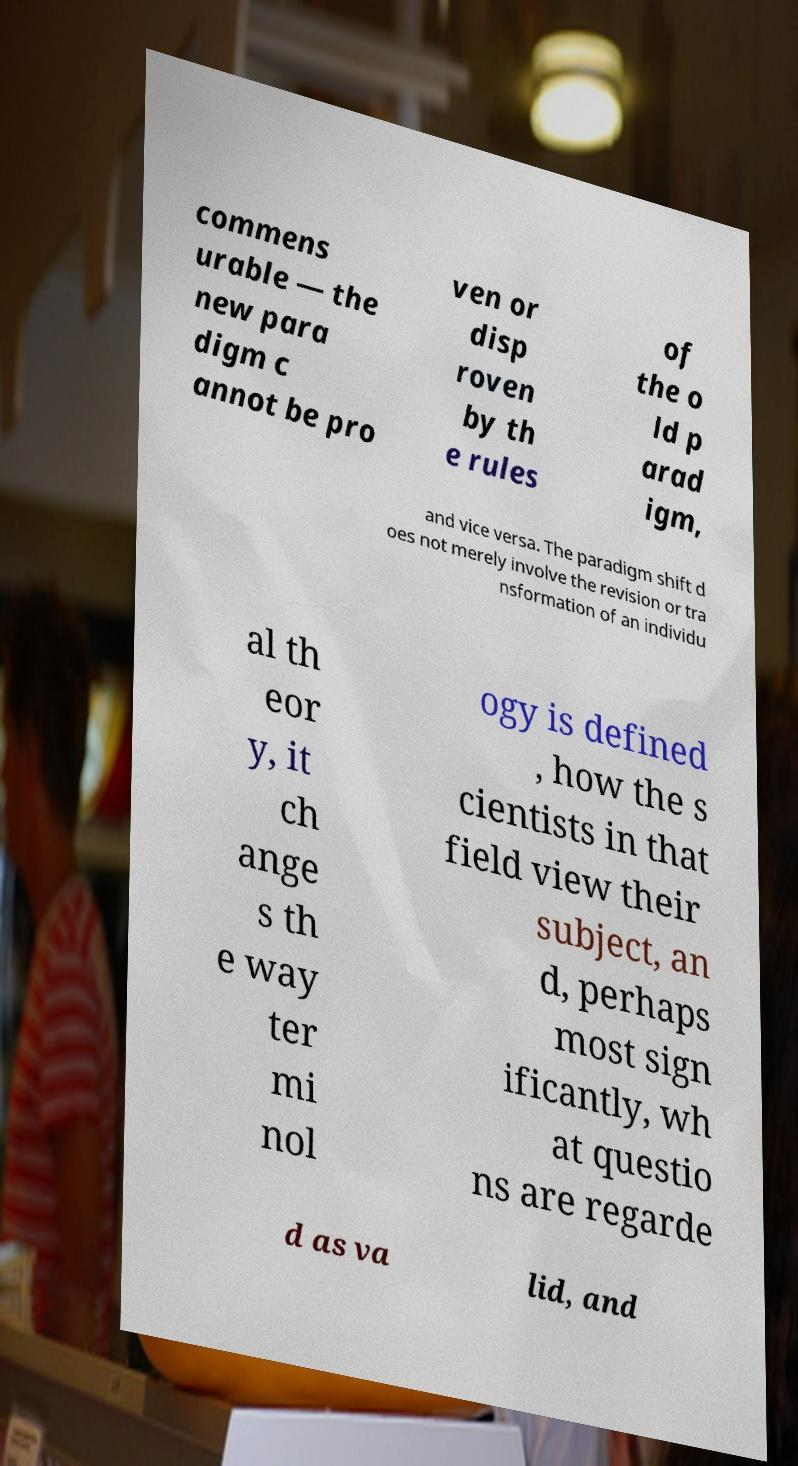What messages or text are displayed in this image? I need them in a readable, typed format. commens urable — the new para digm c annot be pro ven or disp roven by th e rules of the o ld p arad igm, and vice versa. The paradigm shift d oes not merely involve the revision or tra nsformation of an individu al th eor y, it ch ange s th e way ter mi nol ogy is defined , how the s cientists in that field view their subject, an d, perhaps most sign ificantly, wh at questio ns are regarde d as va lid, and 